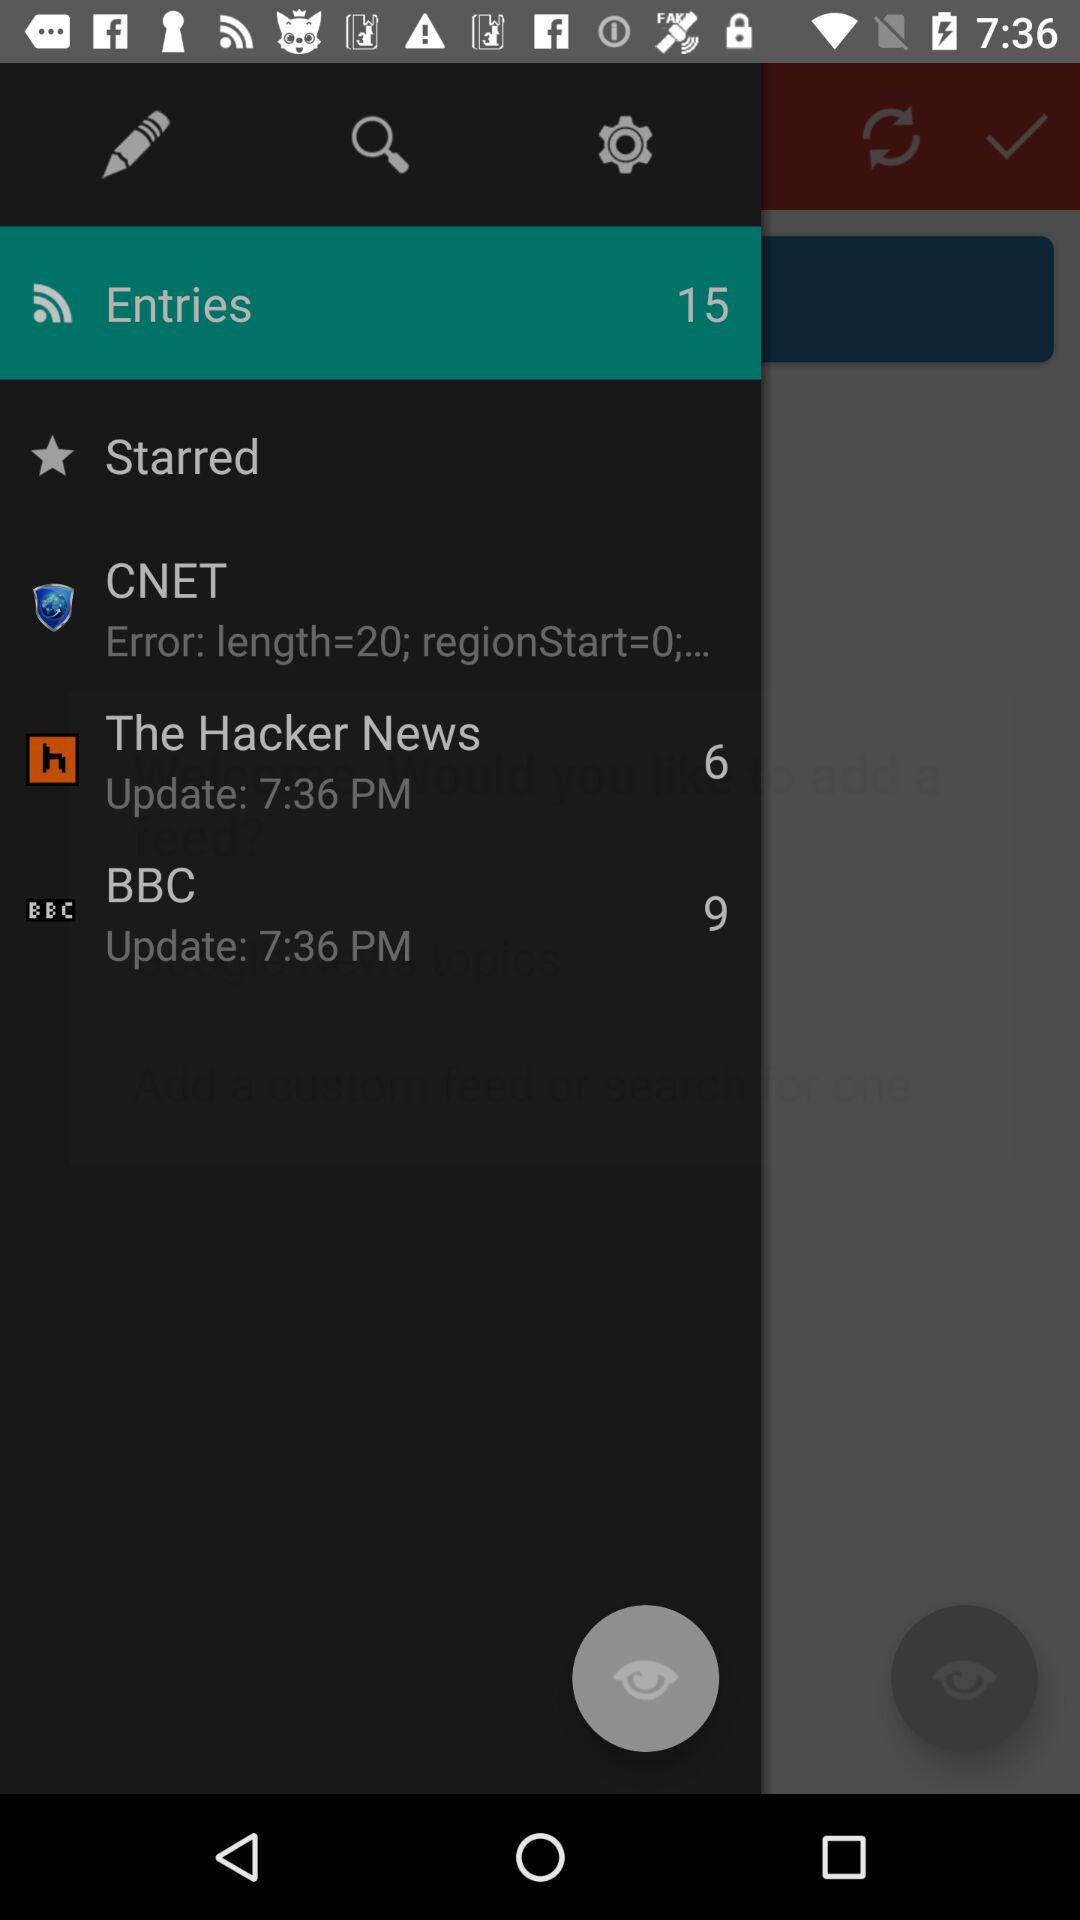At what time was the "BBC" updated? The "BBC" was updated at 7:36 PM. 